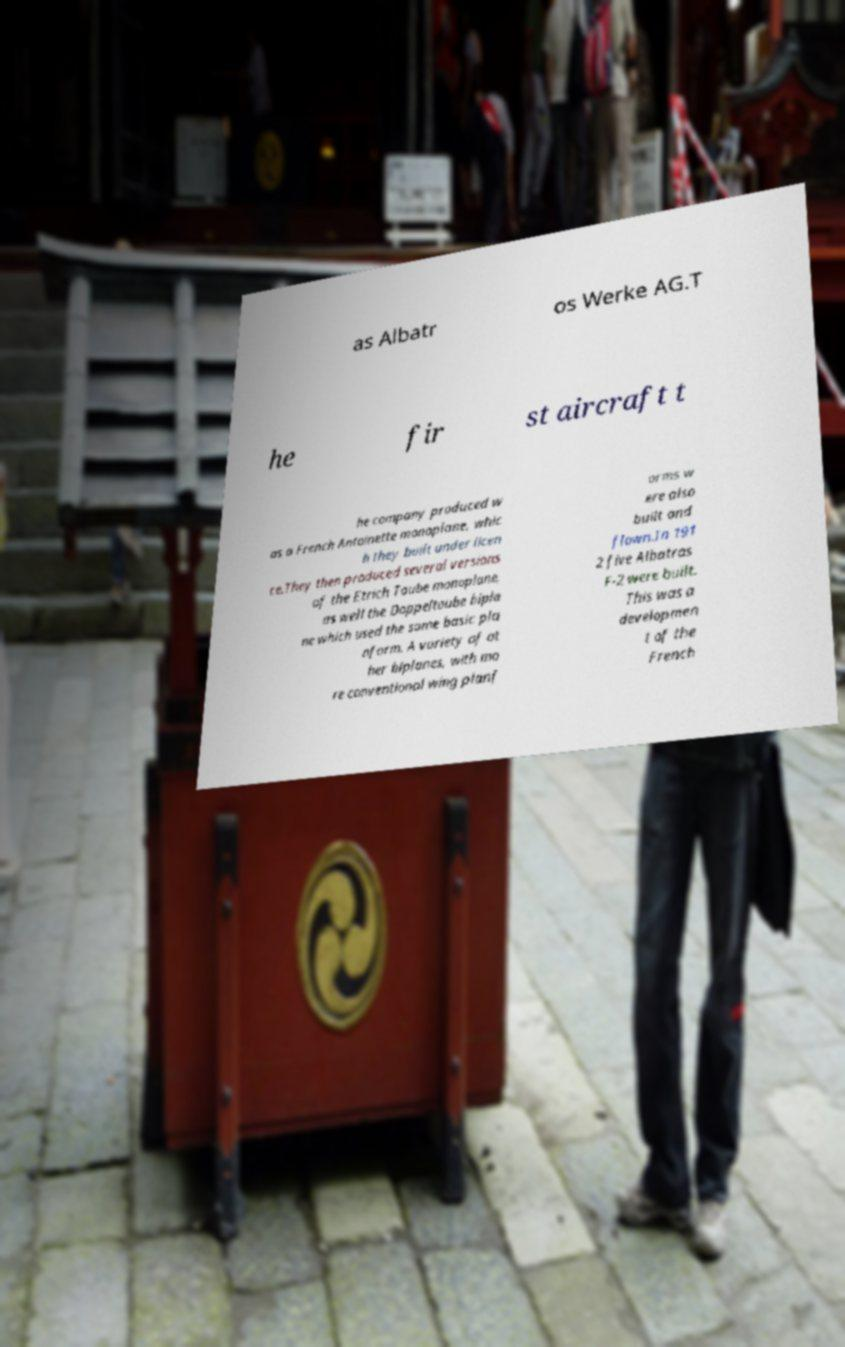Please identify and transcribe the text found in this image. as Albatr os Werke AG.T he fir st aircraft t he company produced w as a French Antoinette monoplane, whic h they built under licen ce.They then produced several versions of the Etrich Taube monoplane, as well the Doppeltaube bipla ne which used the same basic pla nform. A variety of ot her biplanes, with mo re conventional wing planf orms w ere also built and flown.In 191 2 five Albatros F-2 were built. This was a developmen t of the French 